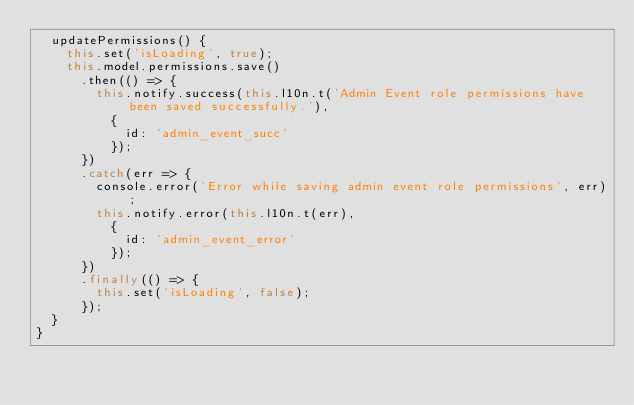<code> <loc_0><loc_0><loc_500><loc_500><_JavaScript_>  updatePermissions() {
    this.set('isLoading', true);
    this.model.permissions.save()
      .then(() => {
        this.notify.success(this.l10n.t('Admin Event role permissions have been saved successfully.'),
          {
            id: 'admin_event_succ'
          });
      })
      .catch(err => {
        console.error('Error while saving admin event role permissions', err);
        this.notify.error(this.l10n.t(err),
          {
            id: 'admin_event_error'
          });
      })
      .finally(() => {
        this.set('isLoading', false);
      });
  }
}
</code> 